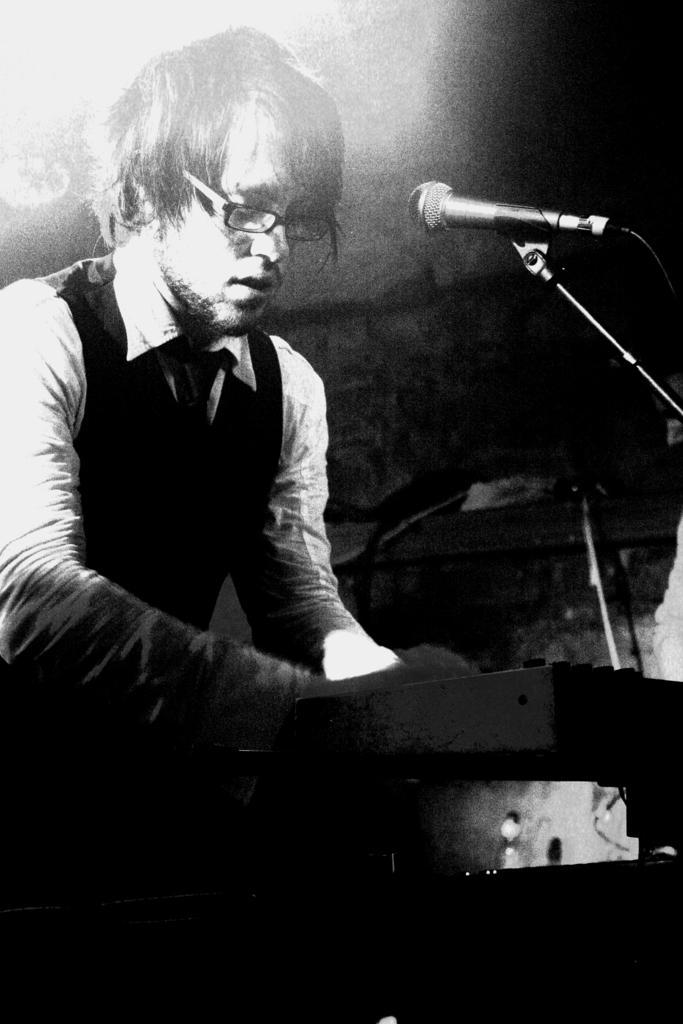How would you summarize this image in a sentence or two? In this image we can see a man wearing spectacles on his face is standing in front of the mic. 